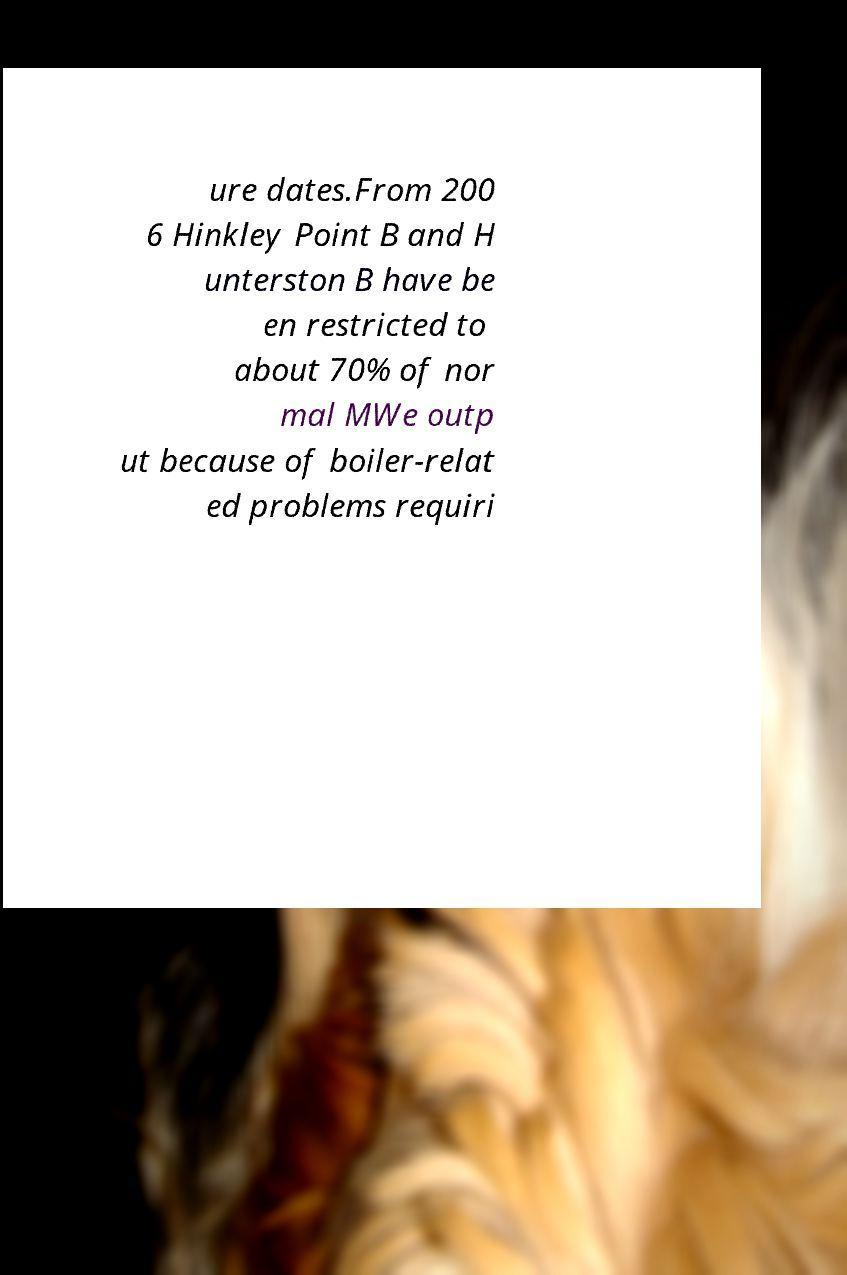Could you assist in decoding the text presented in this image and type it out clearly? ure dates.From 200 6 Hinkley Point B and H unterston B have be en restricted to about 70% of nor mal MWe outp ut because of boiler-relat ed problems requiri 